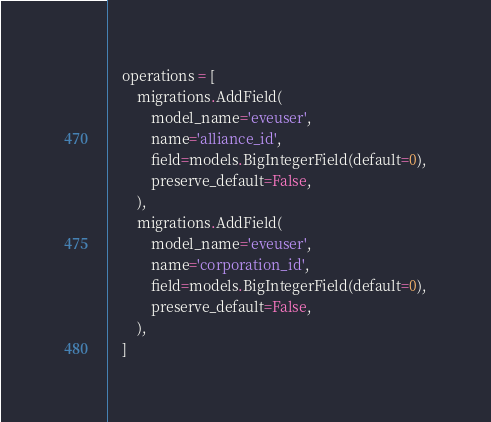Convert code to text. <code><loc_0><loc_0><loc_500><loc_500><_Python_>
    operations = [
        migrations.AddField(
            model_name='eveuser',
            name='alliance_id',
            field=models.BigIntegerField(default=0),
            preserve_default=False,
        ),
        migrations.AddField(
            model_name='eveuser',
            name='corporation_id',
            field=models.BigIntegerField(default=0),
            preserve_default=False,
        ),
    ]
</code> 